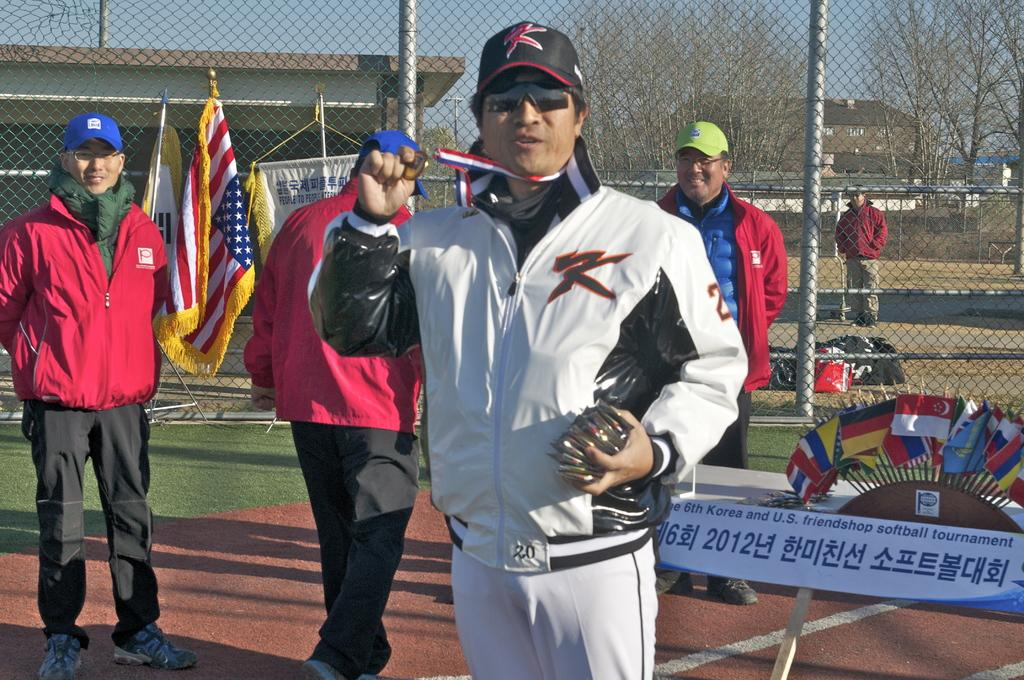<image>
Share a concise interpretation of the image provided. A man in a hat and a white shirt with 20 on it. 